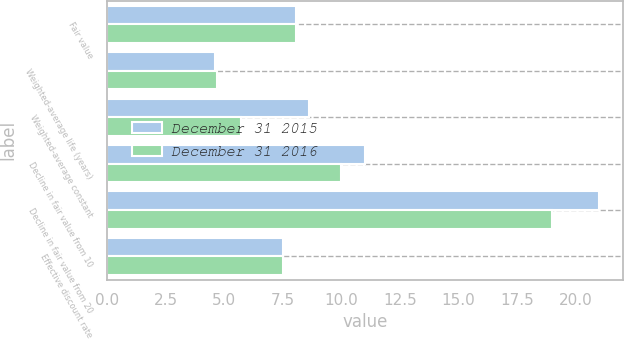<chart> <loc_0><loc_0><loc_500><loc_500><stacked_bar_chart><ecel><fcel>Fair value<fcel>Weighted-average life (years)<fcel>Weighted-average constant<fcel>Decline in fair value from 10<fcel>Decline in fair value from 20<fcel>Effective discount rate<nl><fcel>December 31 2015<fcel>8.065<fcel>4.6<fcel>8.61<fcel>11<fcel>21<fcel>7.52<nl><fcel>December 31 2016<fcel>8.065<fcel>4.7<fcel>5.71<fcel>10<fcel>19<fcel>7.49<nl></chart> 